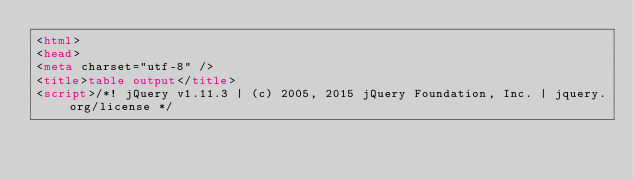Convert code to text. <code><loc_0><loc_0><loc_500><loc_500><_HTML_><html>
<head>
<meta charset="utf-8" />
<title>table output</title>
<script>/*! jQuery v1.11.3 | (c) 2005, 2015 jQuery Foundation, Inc. | jquery.org/license */</code> 